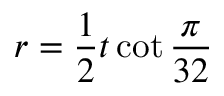<formula> <loc_0><loc_0><loc_500><loc_500>r = { \frac { 1 } { 2 } } t \cot { \frac { \pi } { 3 2 } }</formula> 